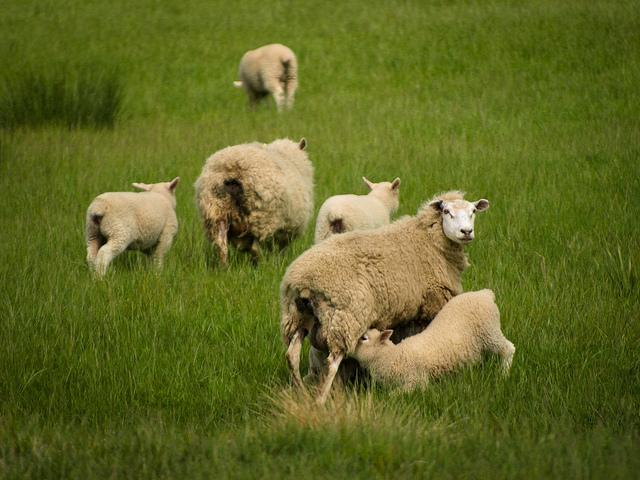What is the baby sheep doing?

Choices:
A) dancing
B) sleeping
C) eating
D) drinking drinking 